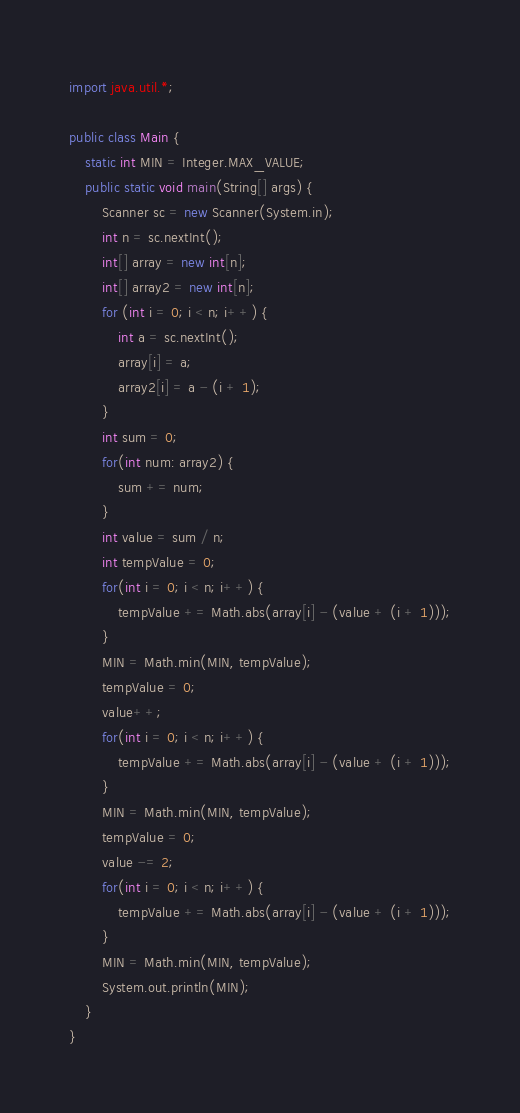Convert code to text. <code><loc_0><loc_0><loc_500><loc_500><_Java_>import java.util.*;

public class Main {
    static int MIN = Integer.MAX_VALUE;
    public static void main(String[] args) {
        Scanner sc = new Scanner(System.in);
        int n = sc.nextInt();
        int[] array = new int[n];
        int[] array2 = new int[n];
        for (int i = 0; i < n; i++) {
            int a = sc.nextInt();
            array[i] = a;
            array2[i] = a - (i + 1);
        }
        int sum = 0;
        for(int num: array2) {
            sum += num;
        }
        int value = sum / n;
        int tempValue = 0;
        for(int i = 0; i < n; i++) {
            tempValue += Math.abs(array[i] - (value + (i + 1)));
        }
        MIN = Math.min(MIN, tempValue);
        tempValue = 0;
        value++;
        for(int i = 0; i < n; i++) {
            tempValue += Math.abs(array[i] - (value + (i + 1)));
        }
        MIN = Math.min(MIN, tempValue);
        tempValue = 0;
        value -= 2;
        for(int i = 0; i < n; i++) {
            tempValue += Math.abs(array[i] - (value + (i + 1)));
        }
        MIN = Math.min(MIN, tempValue);
        System.out.println(MIN);
    }
}</code> 